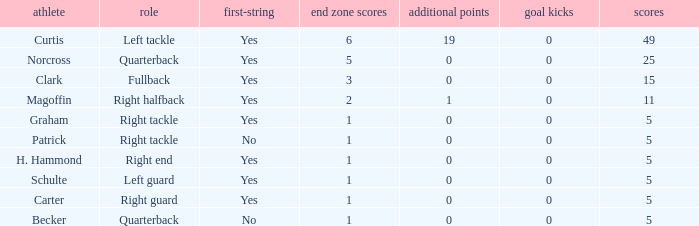Give me the full table as a dictionary. {'header': ['athlete', 'role', 'first-string', 'end zone scores', 'additional points', 'goal kicks', 'scores'], 'rows': [['Curtis', 'Left tackle', 'Yes', '6', '19', '0', '49'], ['Norcross', 'Quarterback', 'Yes', '5', '0', '0', '25'], ['Clark', 'Fullback', 'Yes', '3', '0', '0', '15'], ['Magoffin', 'Right halfback', 'Yes', '2', '1', '0', '11'], ['Graham', 'Right tackle', 'Yes', '1', '0', '0', '5'], ['Patrick', 'Right tackle', 'No', '1', '0', '0', '5'], ['H. Hammond', 'Right end', 'Yes', '1', '0', '0', '5'], ['Schulte', 'Left guard', 'Yes', '1', '0', '0', '5'], ['Carter', 'Right guard', 'Yes', '1', '0', '0', '5'], ['Becker', 'Quarterback', 'No', '1', '0', '0', '5']]} Name the extra points for left guard 0.0. 